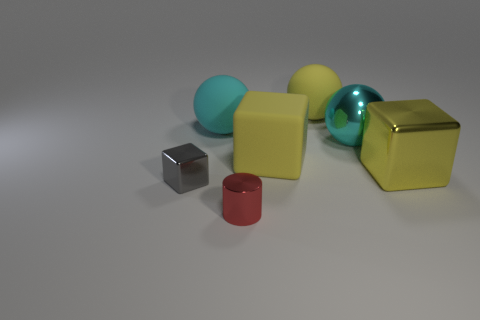Add 2 small red objects. How many objects exist? 9 Subtract all large metal balls. How many balls are left? 2 Subtract 1 spheres. How many spheres are left? 2 Subtract all cylinders. How many objects are left? 6 Subtract all yellow cubes. How many cubes are left? 1 Add 3 big metallic things. How many big metallic things exist? 5 Subtract 2 cyan spheres. How many objects are left? 5 Subtract all yellow balls. Subtract all red cylinders. How many balls are left? 2 Subtract all brown cylinders. How many gray cubes are left? 1 Subtract all large cyan spheres. Subtract all large cyan things. How many objects are left? 3 